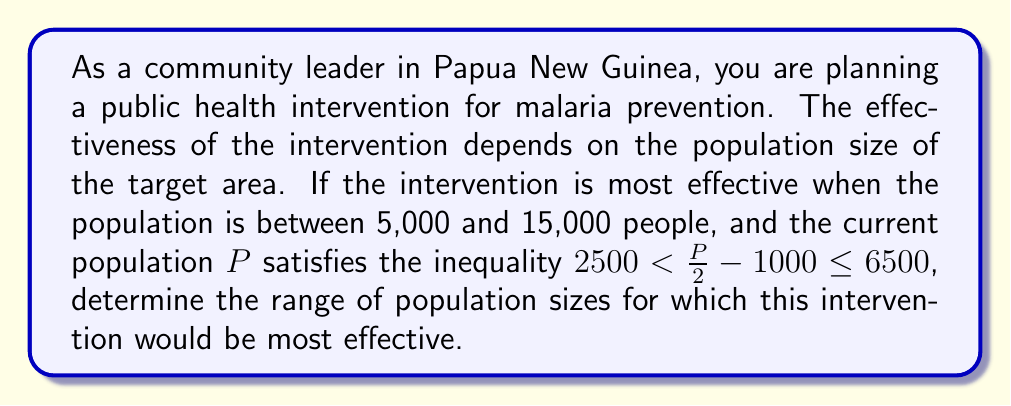Teach me how to tackle this problem. Let's approach this step-by-step:

1) We start with the given inequality:
   $2500 < \frac{P}{2} - 1000 \leq 6500$

2) To isolate $P$, we first add 1000 to all parts of the inequality:
   $3500 < \frac{P}{2} \leq 7500$

3) Now, we multiply all parts by 2:
   $7000 < P \leq 15000$

4) This gives us the range of the current population $P$.

5) However, we need to check if this range overlaps with the effective range for the intervention (5,000 to 15,000).

6) The lower bound of our population (7,000) is already above the minimum effective population (5,000).

7) The upper bound of our population (15,000) is exactly the same as the maximum effective population (15,000).

8) Therefore, the range of population sizes for which this intervention would be most effective is the intersection of these two ranges:
   $\max(5000, 7000) \leq P \leq \min(15000, 15000)$

9) This simplifies to:
   $7000 \leq P \leq 15000$
Answer: The intervention would be most effective for population sizes $P$ satisfying:
$$7000 \leq P \leq 15000$$ 